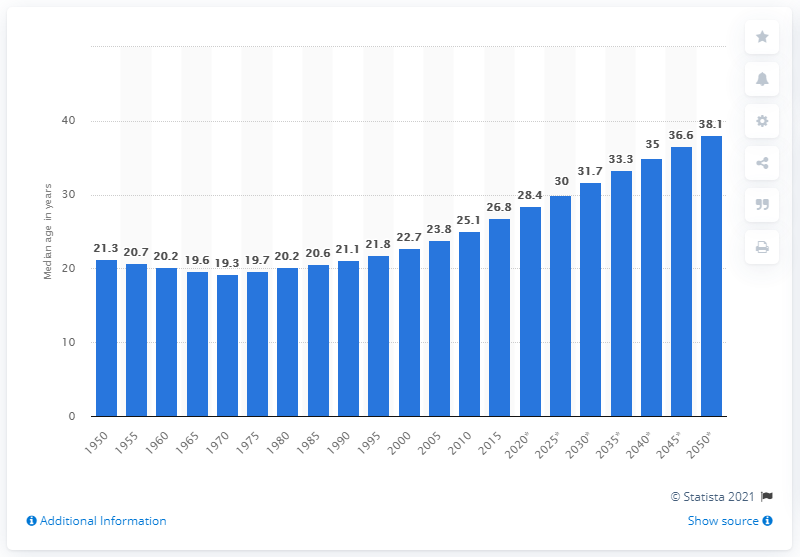Identify some key points in this picture. In 2015, the median age in India was 26.8 years old. 